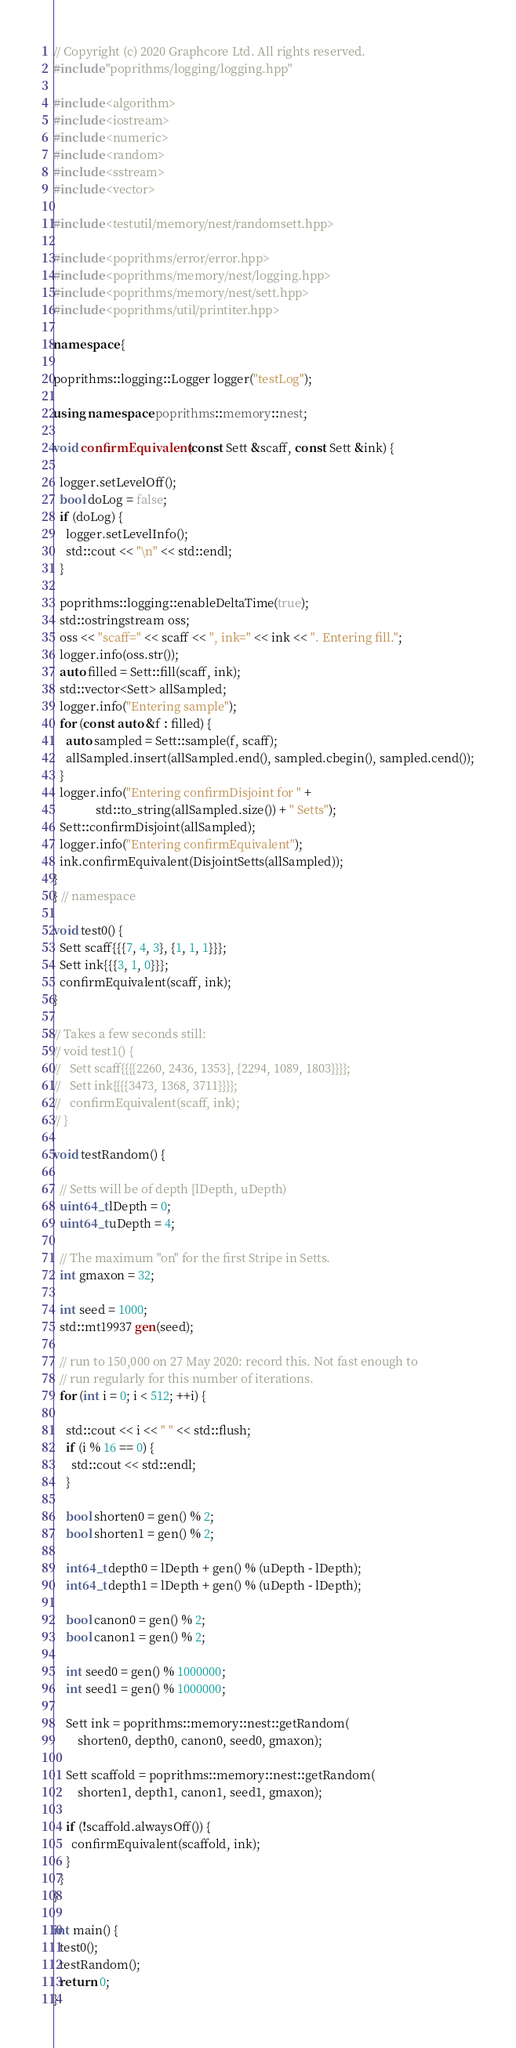Convert code to text. <code><loc_0><loc_0><loc_500><loc_500><_C++_>// Copyright (c) 2020 Graphcore Ltd. All rights reserved.
#include "poprithms/logging/logging.hpp"

#include <algorithm>
#include <iostream>
#include <numeric>
#include <random>
#include <sstream>
#include <vector>

#include <testutil/memory/nest/randomsett.hpp>

#include <poprithms/error/error.hpp>
#include <poprithms/memory/nest/logging.hpp>
#include <poprithms/memory/nest/sett.hpp>
#include <poprithms/util/printiter.hpp>

namespace {

poprithms::logging::Logger logger("testLog");

using namespace poprithms::memory::nest;

void confirmEquivalent(const Sett &scaff, const Sett &ink) {

  logger.setLevelOff();
  bool doLog = false;
  if (doLog) {
    logger.setLevelInfo();
    std::cout << "\n" << std::endl;
  }

  poprithms::logging::enableDeltaTime(true);
  std::ostringstream oss;
  oss << "scaff=" << scaff << ", ink=" << ink << ". Entering fill.";
  logger.info(oss.str());
  auto filled = Sett::fill(scaff, ink);
  std::vector<Sett> allSampled;
  logger.info("Entering sample");
  for (const auto &f : filled) {
    auto sampled = Sett::sample(f, scaff);
    allSampled.insert(allSampled.end(), sampled.cbegin(), sampled.cend());
  }
  logger.info("Entering confirmDisjoint for " +
              std::to_string(allSampled.size()) + " Setts");
  Sett::confirmDisjoint(allSampled);
  logger.info("Entering confirmEquivalent");
  ink.confirmEquivalent(DisjointSetts(allSampled));
}
} // namespace

void test0() {
  Sett scaff{{{7, 4, 3}, {1, 1, 1}}};
  Sett ink{{{3, 1, 0}}};
  confirmEquivalent(scaff, ink);
}

// Takes a few seconds still:
// void test1() {
//   Sett scaff{{{{2260, 2436, 1353}, {2294, 1089, 1803}}}};
//   Sett ink{{{{3473, 1368, 3711}}}};
//   confirmEquivalent(scaff, ink);
// }

void testRandom() {

  // Setts will be of depth [lDepth, uDepth)
  uint64_t lDepth = 0;
  uint64_t uDepth = 4;

  // The maximum "on" for the first Stripe in Setts.
  int gmaxon = 32;

  int seed = 1000;
  std::mt19937 gen(seed);

  // run to 150,000 on 27 May 2020: record this. Not fast enough to
  // run regularly for this number of iterations.
  for (int i = 0; i < 512; ++i) {

    std::cout << i << " " << std::flush;
    if (i % 16 == 0) {
      std::cout << std::endl;
    }

    bool shorten0 = gen() % 2;
    bool shorten1 = gen() % 2;

    int64_t depth0 = lDepth + gen() % (uDepth - lDepth);
    int64_t depth1 = lDepth + gen() % (uDepth - lDepth);

    bool canon0 = gen() % 2;
    bool canon1 = gen() % 2;

    int seed0 = gen() % 1000000;
    int seed1 = gen() % 1000000;

    Sett ink = poprithms::memory::nest::getRandom(
        shorten0, depth0, canon0, seed0, gmaxon);

    Sett scaffold = poprithms::memory::nest::getRandom(
        shorten1, depth1, canon1, seed1, gmaxon);

    if (!scaffold.alwaysOff()) {
      confirmEquivalent(scaffold, ink);
    }
  }
}

int main() {
  test0();
  testRandom();
  return 0;
}
</code> 